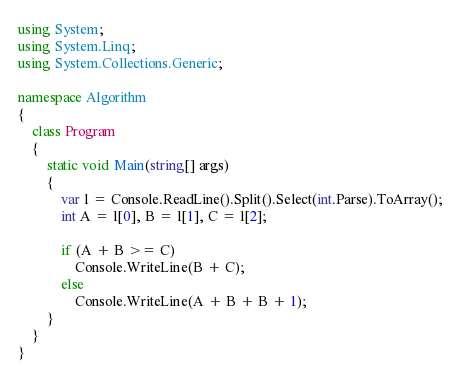<code> <loc_0><loc_0><loc_500><loc_500><_C#_>using System;
using System.Linq;
using System.Collections.Generic;

namespace Algorithm
{
    class Program
    {
        static void Main(string[] args)
        {
            var l = Console.ReadLine().Split().Select(int.Parse).ToArray();
            int A = l[0], B = l[1], C = l[2];

            if (A + B >= C)
                Console.WriteLine(B + C);
            else
                Console.WriteLine(A + B + B + 1);
        }
    }
}
</code> 